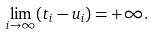<formula> <loc_0><loc_0><loc_500><loc_500>\lim _ { i \to \infty } ( t _ { i } - u _ { i } ) = + \infty .</formula> 